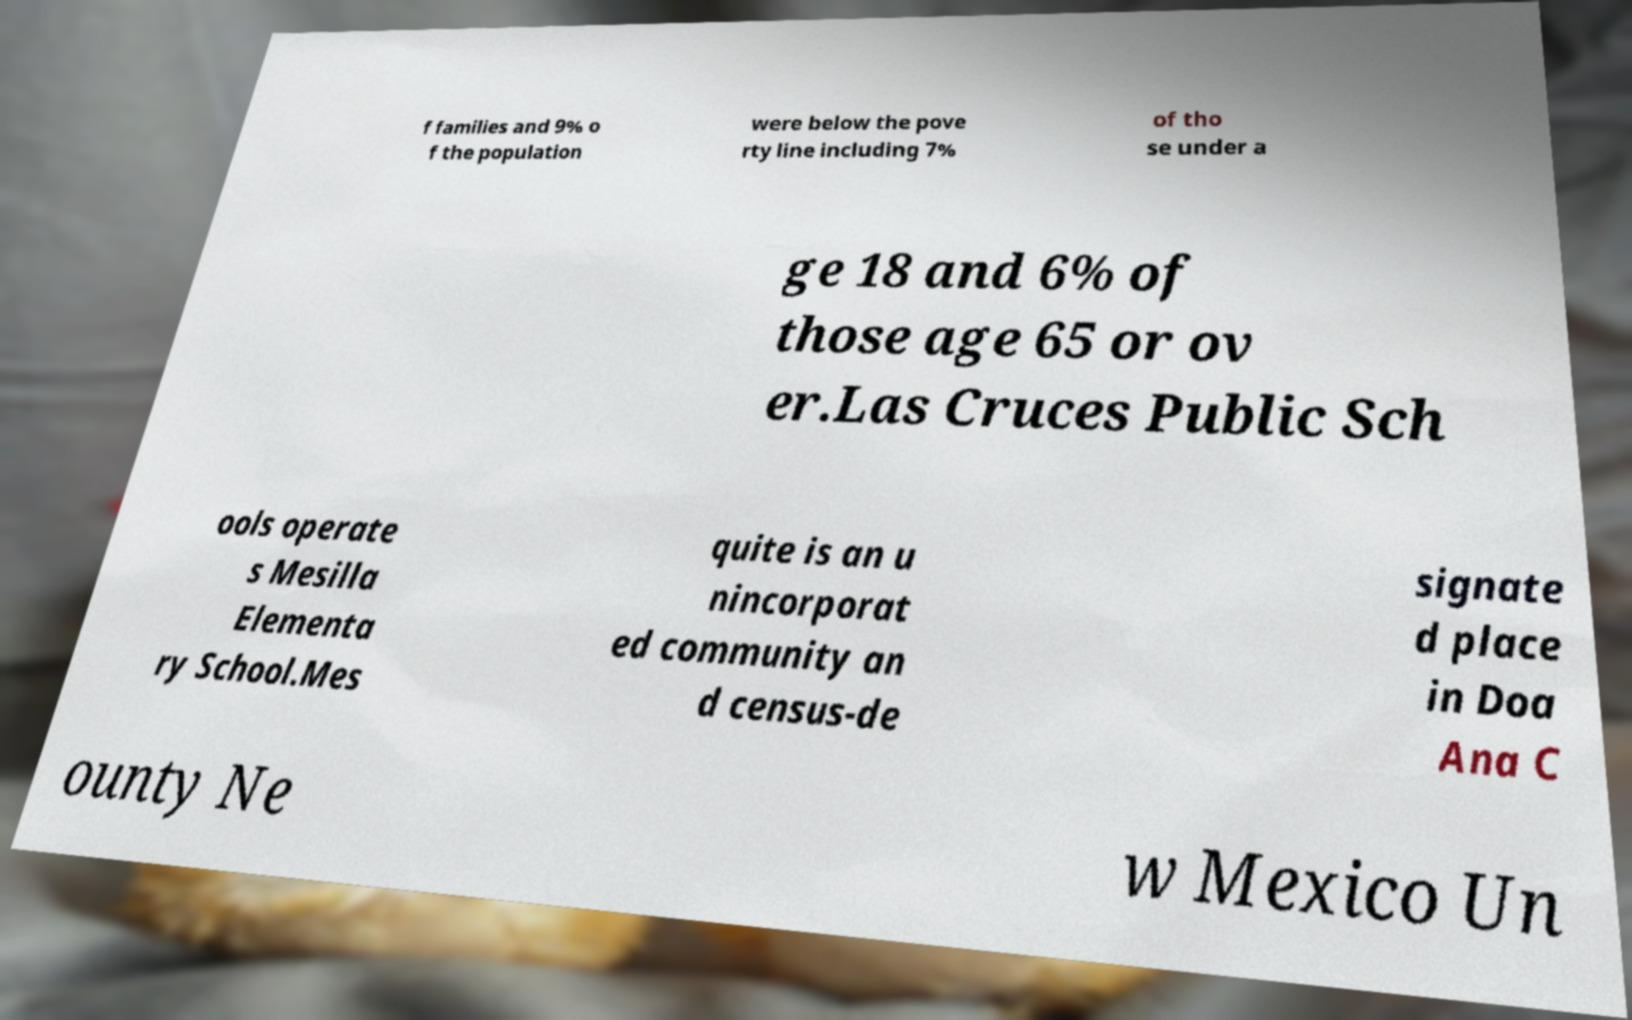Please identify and transcribe the text found in this image. f families and 9% o f the population were below the pove rty line including 7% of tho se under a ge 18 and 6% of those age 65 or ov er.Las Cruces Public Sch ools operate s Mesilla Elementa ry School.Mes quite is an u nincorporat ed community an d census-de signate d place in Doa Ana C ounty Ne w Mexico Un 